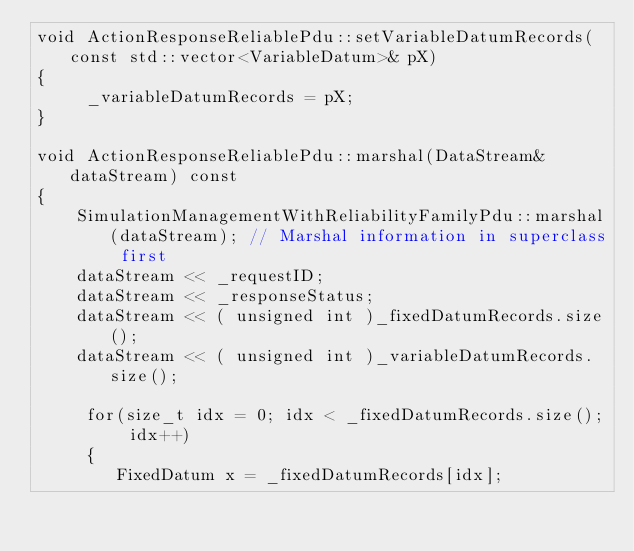<code> <loc_0><loc_0><loc_500><loc_500><_C++_>void ActionResponseReliablePdu::setVariableDatumRecords(const std::vector<VariableDatum>& pX)
{
     _variableDatumRecords = pX;
}

void ActionResponseReliablePdu::marshal(DataStream& dataStream) const
{
    SimulationManagementWithReliabilityFamilyPdu::marshal(dataStream); // Marshal information in superclass first
    dataStream << _requestID;
    dataStream << _responseStatus;
    dataStream << ( unsigned int )_fixedDatumRecords.size();
    dataStream << ( unsigned int )_variableDatumRecords.size();

     for(size_t idx = 0; idx < _fixedDatumRecords.size(); idx++)
     {
        FixedDatum x = _fixedDatumRecords[idx];</code> 